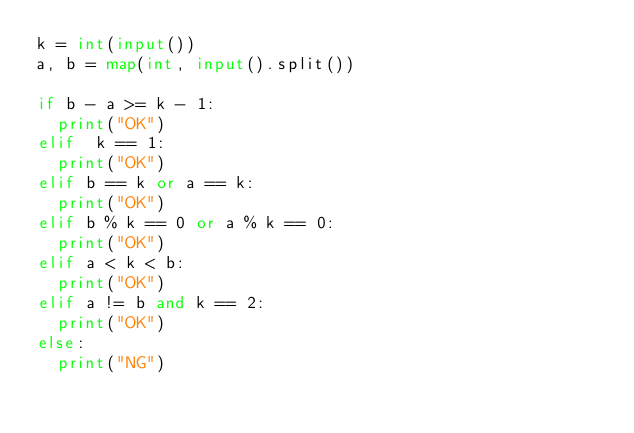Convert code to text. <code><loc_0><loc_0><loc_500><loc_500><_Python_>k = int(input())
a, b = map(int, input().split())

if b - a >= k - 1:
  print("OK")
elif  k == 1:
  print("OK")
elif b == k or a == k:
  print("OK")
elif b % k == 0 or a % k == 0:
  print("OK")
elif a < k < b:
  print("OK")
elif a != b and k == 2:
  print("OK")
else:
  print("NG")

</code> 